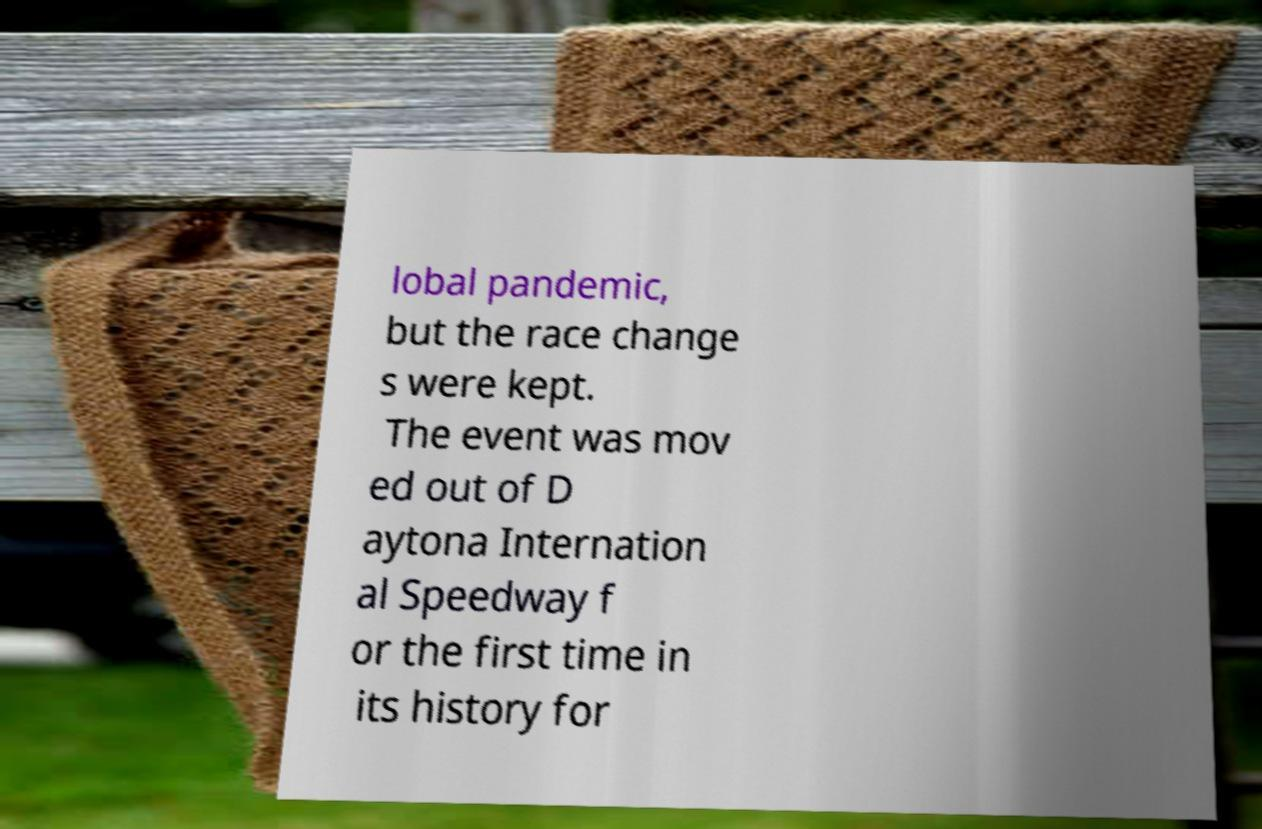What messages or text are displayed in this image? I need them in a readable, typed format. lobal pandemic, but the race change s were kept. The event was mov ed out of D aytona Internation al Speedway f or the first time in its history for 